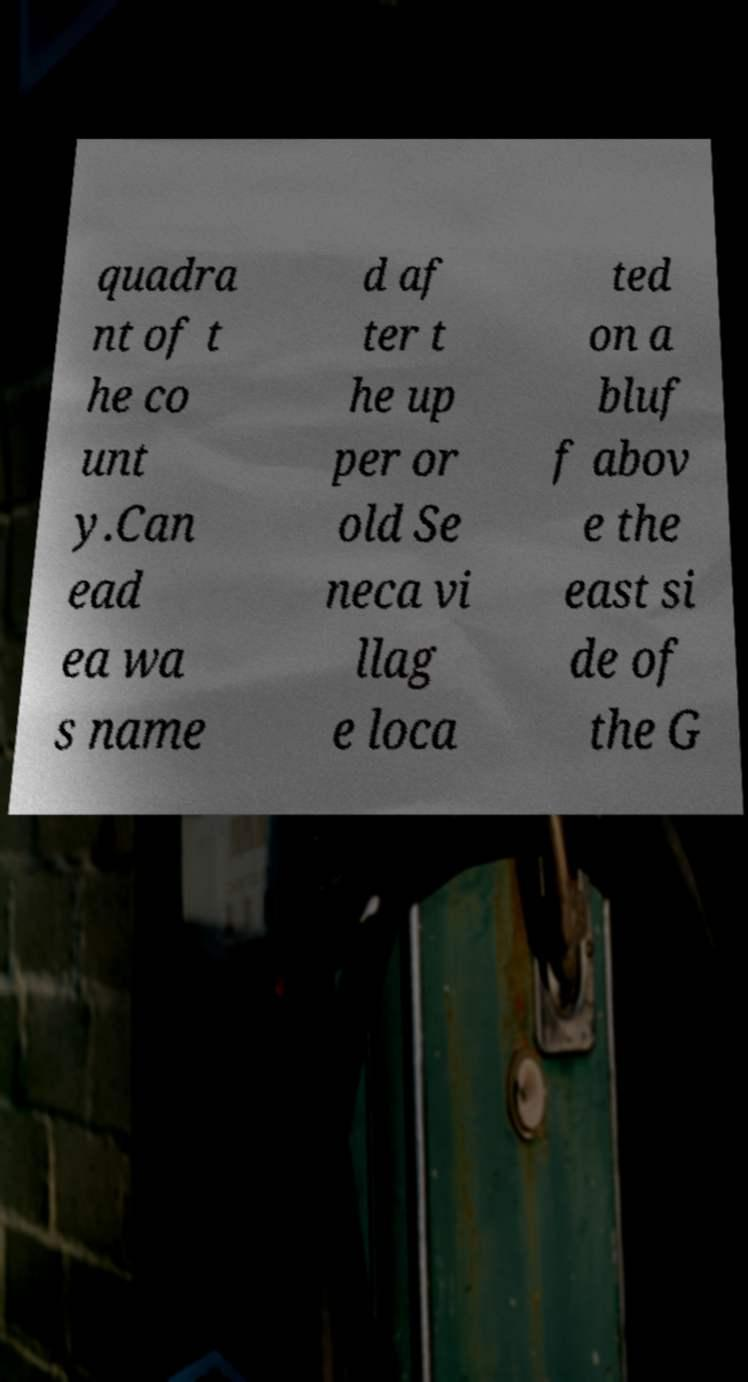I need the written content from this picture converted into text. Can you do that? quadra nt of t he co unt y.Can ead ea wa s name d af ter t he up per or old Se neca vi llag e loca ted on a bluf f abov e the east si de of the G 